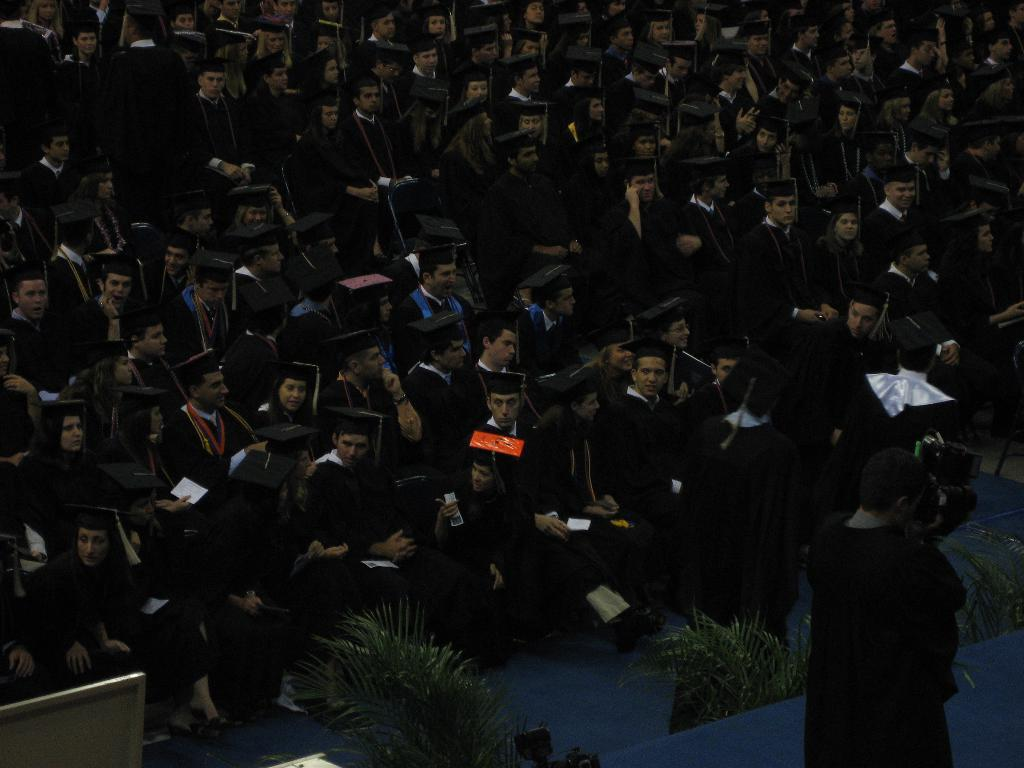How many people are in the image? There are people in the image, but the exact number is not specified. What can be seen beneath the people in the image? The ground is visible in the image. What type of vegetation is present in the image? There are plants in the image. What color is the object on the left side of the image? There is a white colored object on the left side of the image. What type of army is depicted in the image? There is no army present in the image; it features people, ground, plants, and a white colored object. 